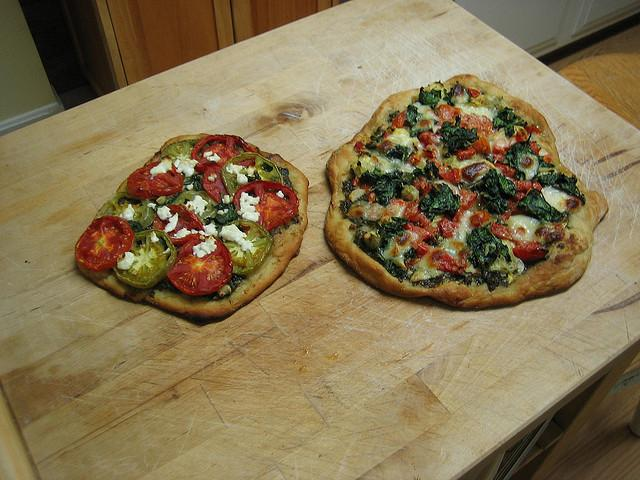What are the green vegetables next to the red tomatoes on the left-side pizza? peppers 